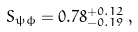Convert formula to latex. <formula><loc_0><loc_0><loc_500><loc_500>S _ { \psi \phi } = 0 . 7 8 ^ { + 0 . 1 2 } _ { - 0 . 1 9 } \, ,</formula> 